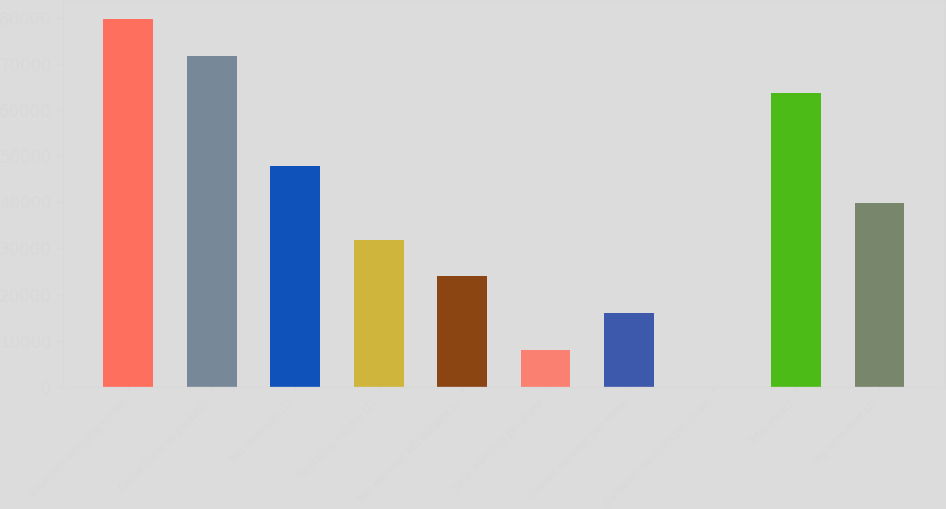Convert chart to OTSL. <chart><loc_0><loc_0><loc_500><loc_500><bar_chart><fcel>Revenues including excise<fcel>Excise taxes on products<fcel>Net revenues (1)<fcel>Operating income (1)<fcel>Net earnings attributable to<fcel>Basic earnings per share<fcel>Diluted earnings per share<fcel>Dividends declared per share<fcel>Total assets<fcel>Long-term debt (2)<nl><fcel>79823<fcel>71841.1<fcel>47895.6<fcel>31931.9<fcel>23950<fcel>7986.34<fcel>15968.2<fcel>4.49<fcel>63859.3<fcel>39913.7<nl></chart> 